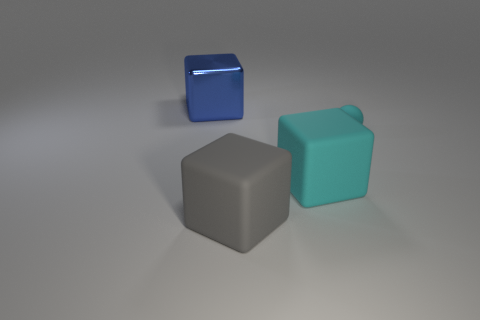Add 1 blue rubber cylinders. How many objects exist? 5 Subtract all large gray cubes. How many cubes are left? 2 Subtract all cyan cylinders. How many blue cubes are left? 1 Subtract all blue blocks. How many blocks are left? 2 Subtract 0 yellow cylinders. How many objects are left? 4 Subtract all cubes. How many objects are left? 1 Subtract all gray blocks. Subtract all cyan cylinders. How many blocks are left? 2 Subtract all gray blocks. Subtract all cyan things. How many objects are left? 1 Add 1 large blue shiny blocks. How many large blue shiny blocks are left? 2 Add 2 big rubber objects. How many big rubber objects exist? 4 